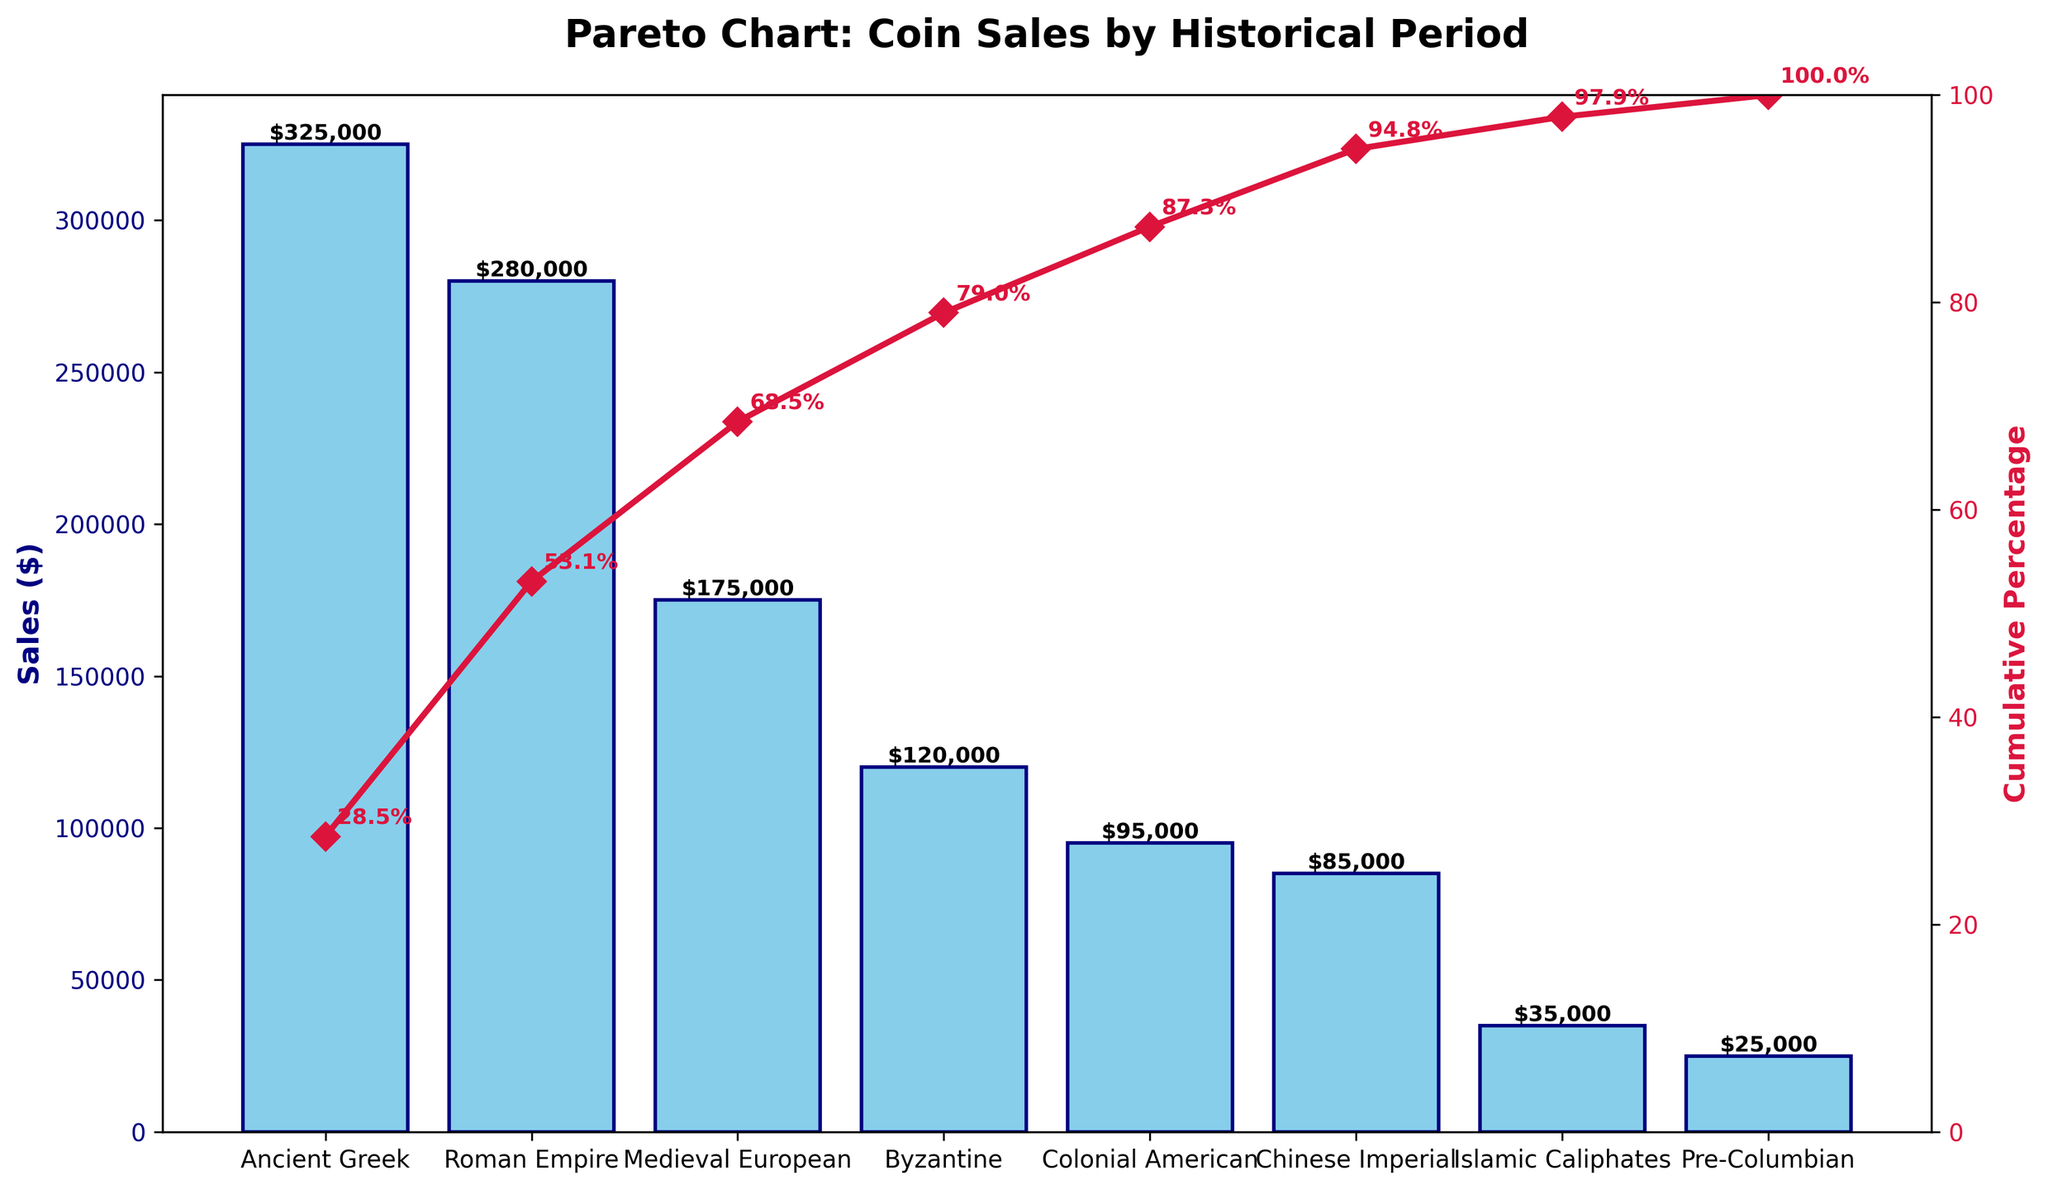what is the title of the chart? The title of the chart is visible at the top and it reads 'Pareto Chart: Coin Sales by Historical Period'.
Answer: Pareto Chart: Coin Sales by Historical Period How many historical periods are represented in the chart? Count the distinct data points (bars) on the x-axis, each representing a historical period.
Answer: 8 Which historical period has the highest sales? Look at the highest bar on the chart, which represents the historical period with the maximum sales. It is labeled as 'Ancient Greek'.
Answer: Ancient Greek What is the cumulative percentage after including Roman Empire sales? The Roman Empire is the second-period listed. Observe the cumulative percentage line and note the value at this point.
Answer: 53.1% What is the difference in sales between Medieval European and Byzantine periods? Locate the bars for Medieval European and Byzantine periods; the heights of the bars represent their sales. Subtract the sales value of the Byzantine period from the Medieval European period.
Answer: $55,000 How much does the Byzantine period contribute to the total revenue? Observe the value labeled on the associated bar; it corresponds to the sales value of the Byzantine period.
Answer: $120,000 What is the cumulative percentage increase when including Pre-Columbian and Islamic Caliphates together? Note the cumulative percentages for Pre-Columbian and Islamic Caliphates, sum these two values to get the combined contribution.
Answer: 5.2% Which historical period is the median value in cumulative percentage? Since there are 8 periods, the median will be between the 4th and 5th periods when listed in descending order. Note their cumulative percentages and find the average.
Answer: Byzantine (53.1%) Which periods combined contribute roughly 70% of the total revenue? Beginning from the highest cumulative percentage, visually add up periods until their cumulative sum approaches 70%. The first four periods should sum up to slightly above 70%.
Answer: Ancient Greek, Roman Empire, Medieval European, Byzantine What is the sales value for the Chinese Imperial period? Identify the bar for the Chinese Imperial period and the numerical label on top of it that represents its sales value.
Answer: $85,000 